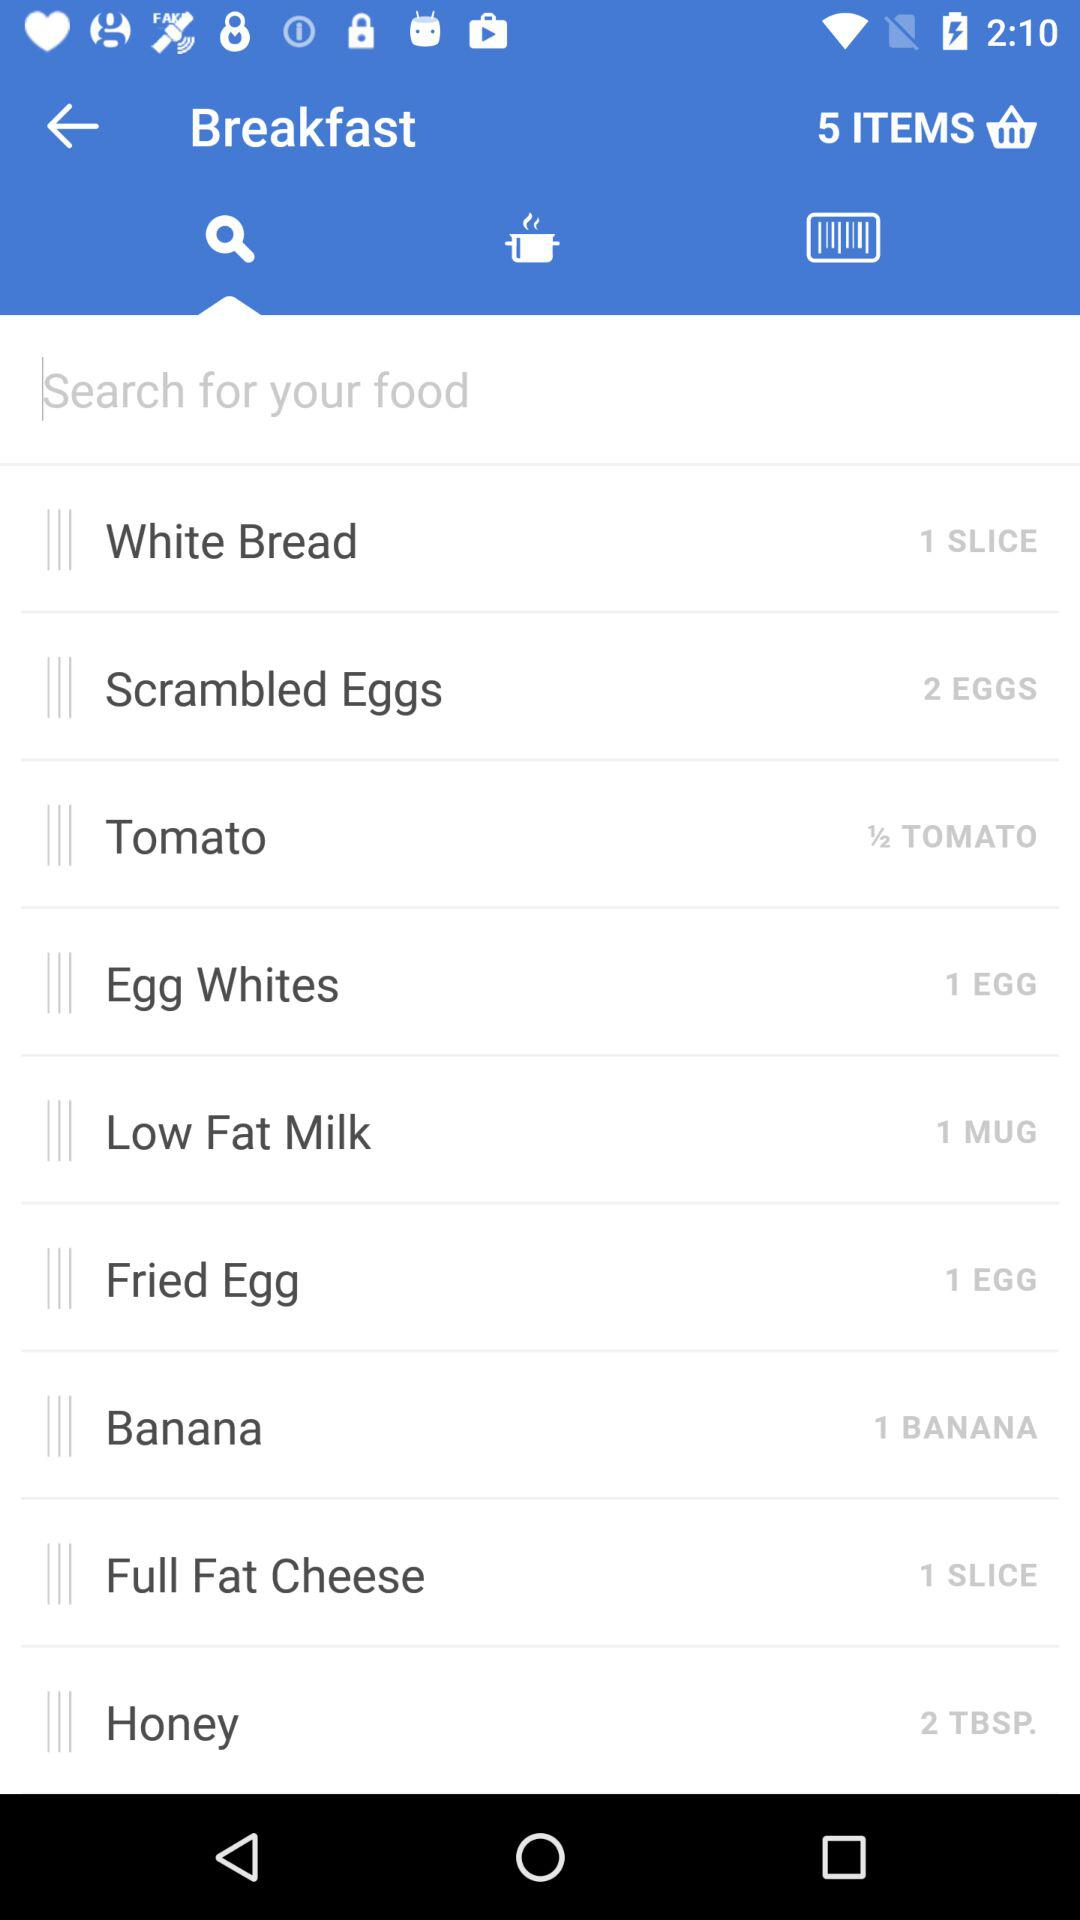How many bananas are available there? There is 1 banana available. 